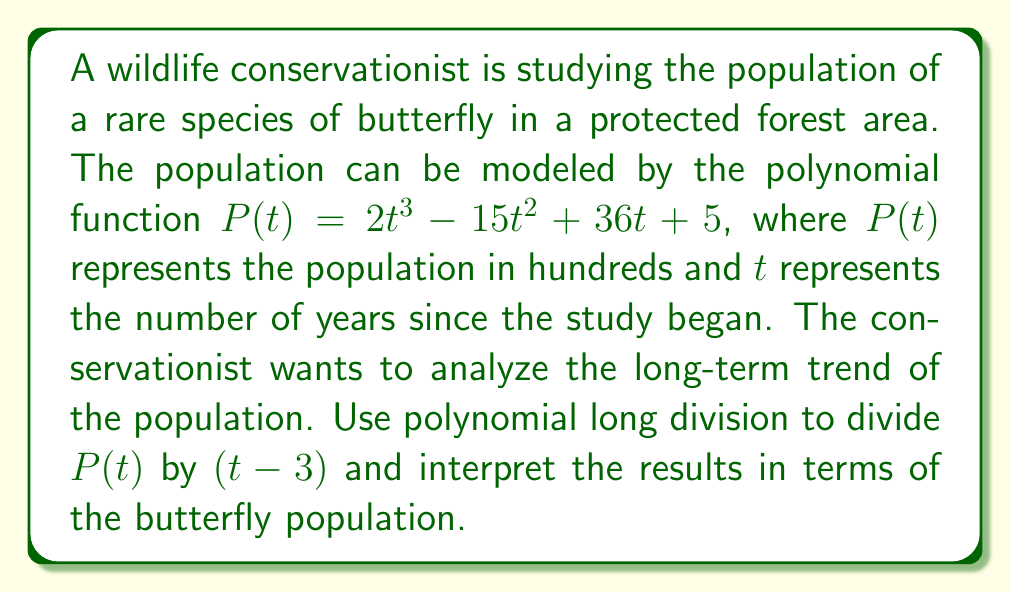Help me with this question. Let's approach this step-by-step:

1) First, we'll perform polynomial long division of $P(t)$ by $(t - 3)$:

   $$\begin{array}{r}
   2t^2 + 6t + 54 \\
   t - 3 \enclose{longdiv}{2t^3 - 15t^2 + 36t + 5} \\
   \underline{2t^3 - 6t^2} \\
   -9t^2 + 36t \\
   \underline{-9t^2 + 27t} \\
   9t + 5 \\
   \underline{9t - 27} \\
   32
   \end{array}$$

2) The result of the division is:
   
   $P(t) = (t - 3)(2t^2 + 6t + 54) + 32$

3) Interpreting this result:
   - The quotient $2t^2 + 6t + 54$ represents the long-term trend of the population.
   - The remainder 32 represents the deviation from this trend when $t = 3$.

4) The fact that $(t - 3)$ was used as the divisor tells us that the population at $t = 3$ years is significant:
   
   $P(3) = 2(3)^3 - 15(3)^2 + 36(3) + 5 = 54 + 32 = 86$

5) This means that after 3 years, the population will be 8,600 butterflies (remember, $P(t)$ is in hundreds).

6) The long-term trend $2t^2 + 6t + 54$ is a quadratic function, which suggests that the population will grow at an increasing rate over time, which is positive news for the conservation effort.

7) The remainder of 32 indicates that at $t = 3$, the actual population (8,600) exceeds what would be predicted by the long-term trend alone by 3,200 butterflies.
Answer: The polynomial division results in $P(t) = (t - 3)(2t^2 + 6t + 54) + 32$. This indicates a long-term quadratic growth trend represented by $2t^2 + 6t + 54$, with the population exceeding this trend by 3,200 butterflies at the 3-year mark. The positive quadratic trend suggests successful conservation efforts leading to accelerating population growth over time. 